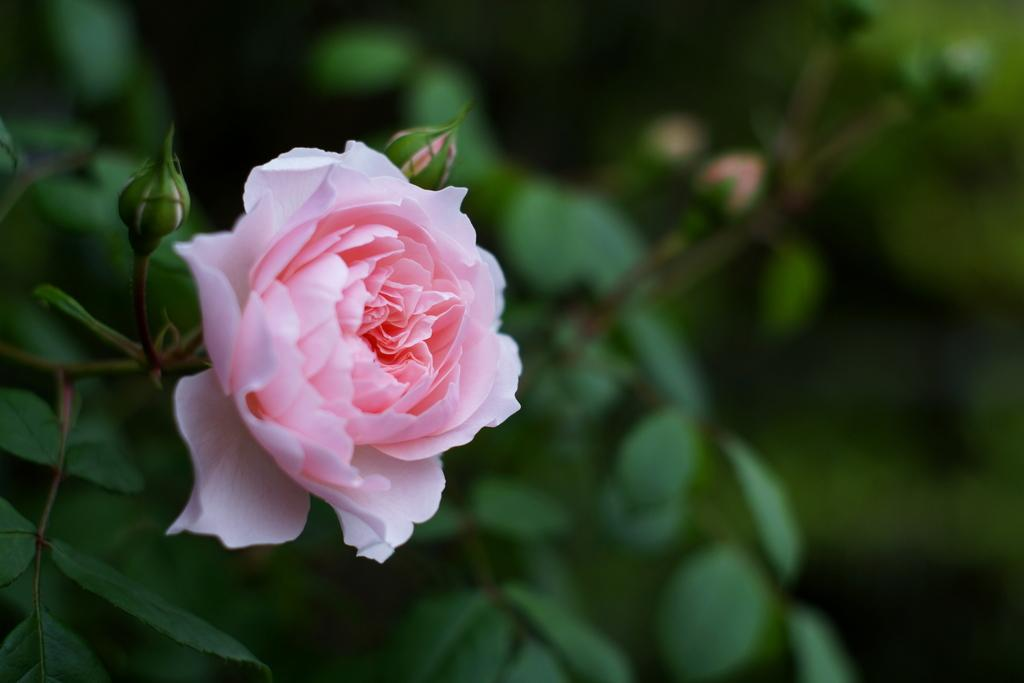What is located on the left side of the image? There is a plant on the left side of the image. What can be observed on the plant? The plant has flowers and buds. How would you describe the background of the image? The background of the image is blurred. What language is the plant speaking in the image? Plants do not speak languages, so this question cannot be answered. 